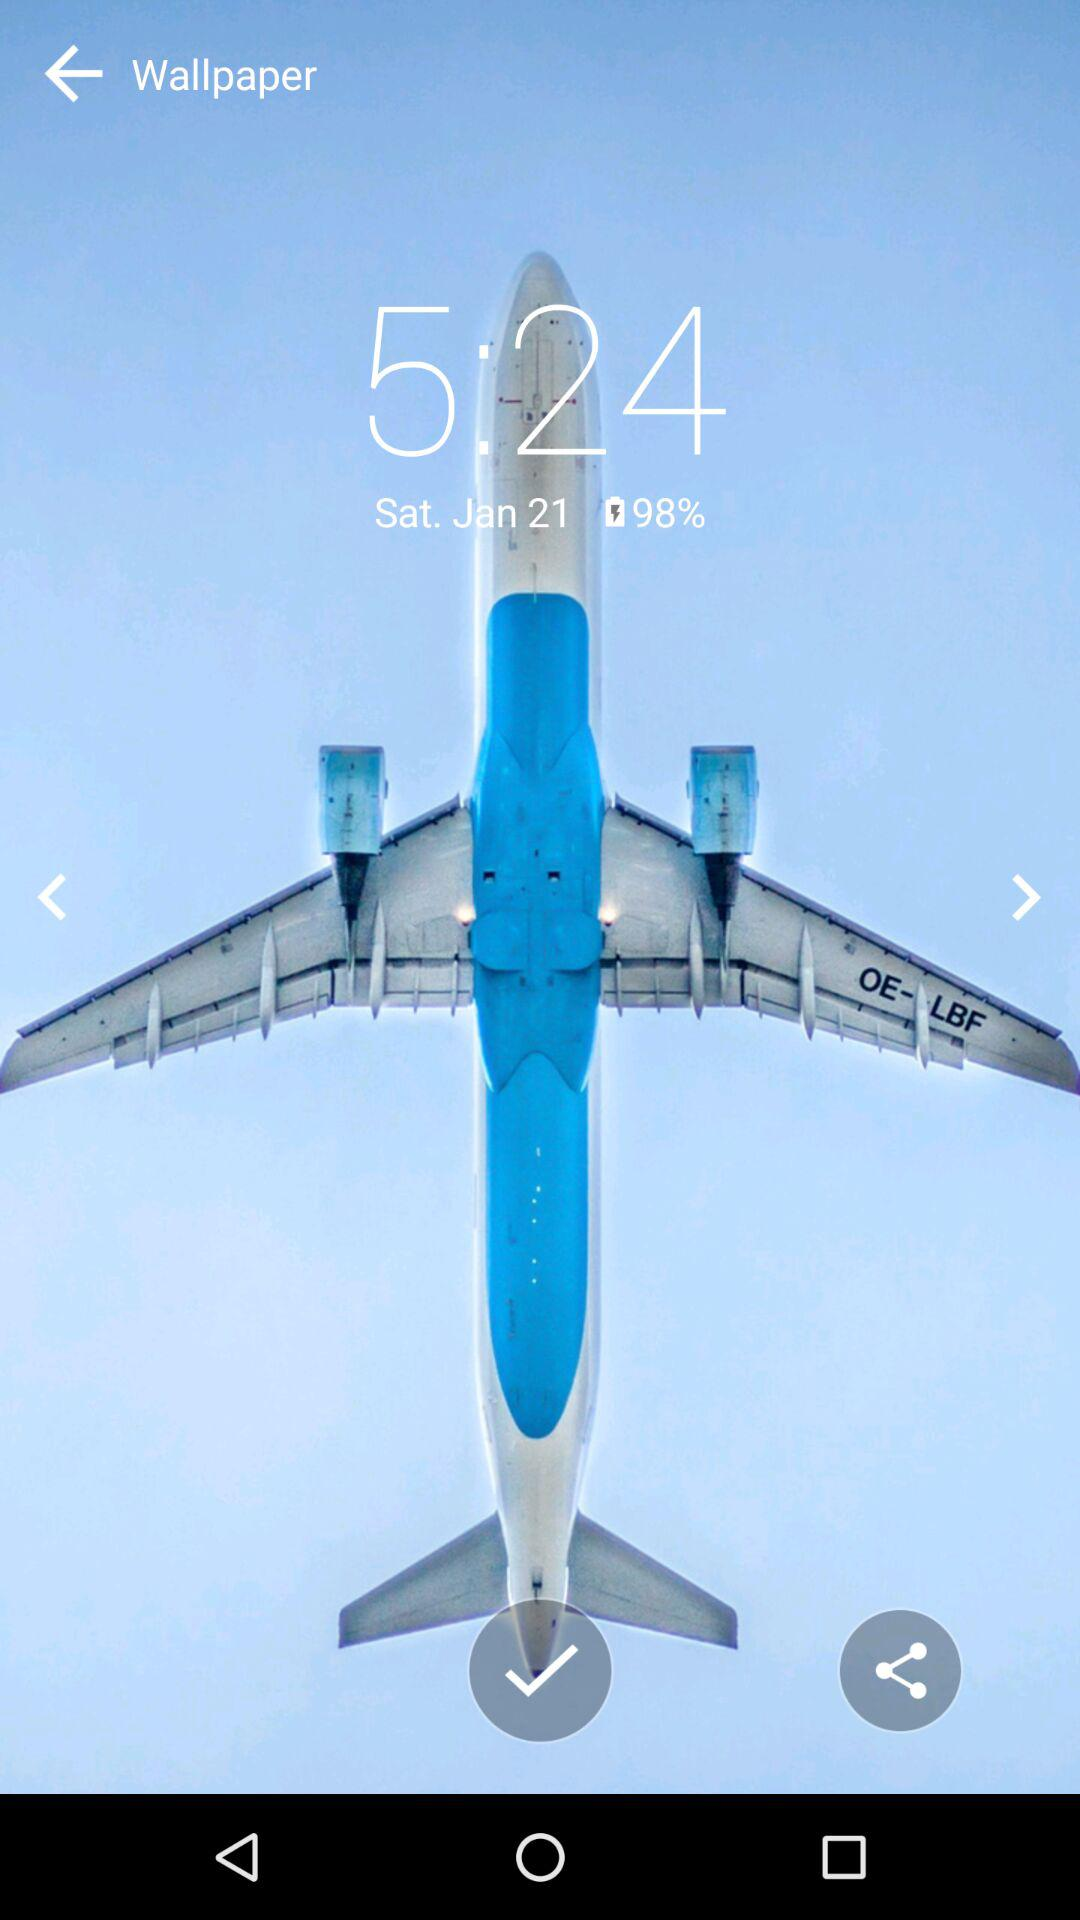What is the time today? The time is 5:24. 